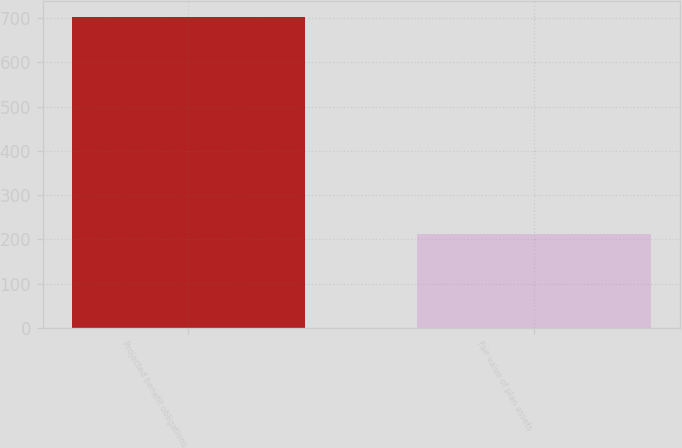Convert chart to OTSL. <chart><loc_0><loc_0><loc_500><loc_500><bar_chart><fcel>Projected benefit obligations<fcel>Fair value of plan assets<nl><fcel>703<fcel>212<nl></chart> 